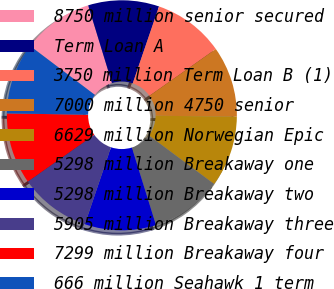Convert chart. <chart><loc_0><loc_0><loc_500><loc_500><pie_chart><fcel>8750 million senior secured<fcel>Term Loan A<fcel>3750 million Term Loan B (1)<fcel>7000 million 4750 senior<fcel>6629 million Norwegian Epic<fcel>5298 million Breakaway one<fcel>5298 million Breakaway two<fcel>5905 million Breakaway three<fcel>7299 million Breakaway four<fcel>666 million Seahawk 1 term<nl><fcel>9.97%<fcel>9.97%<fcel>9.98%<fcel>9.98%<fcel>9.99%<fcel>10.01%<fcel>10.01%<fcel>10.02%<fcel>10.03%<fcel>10.04%<nl></chart> 